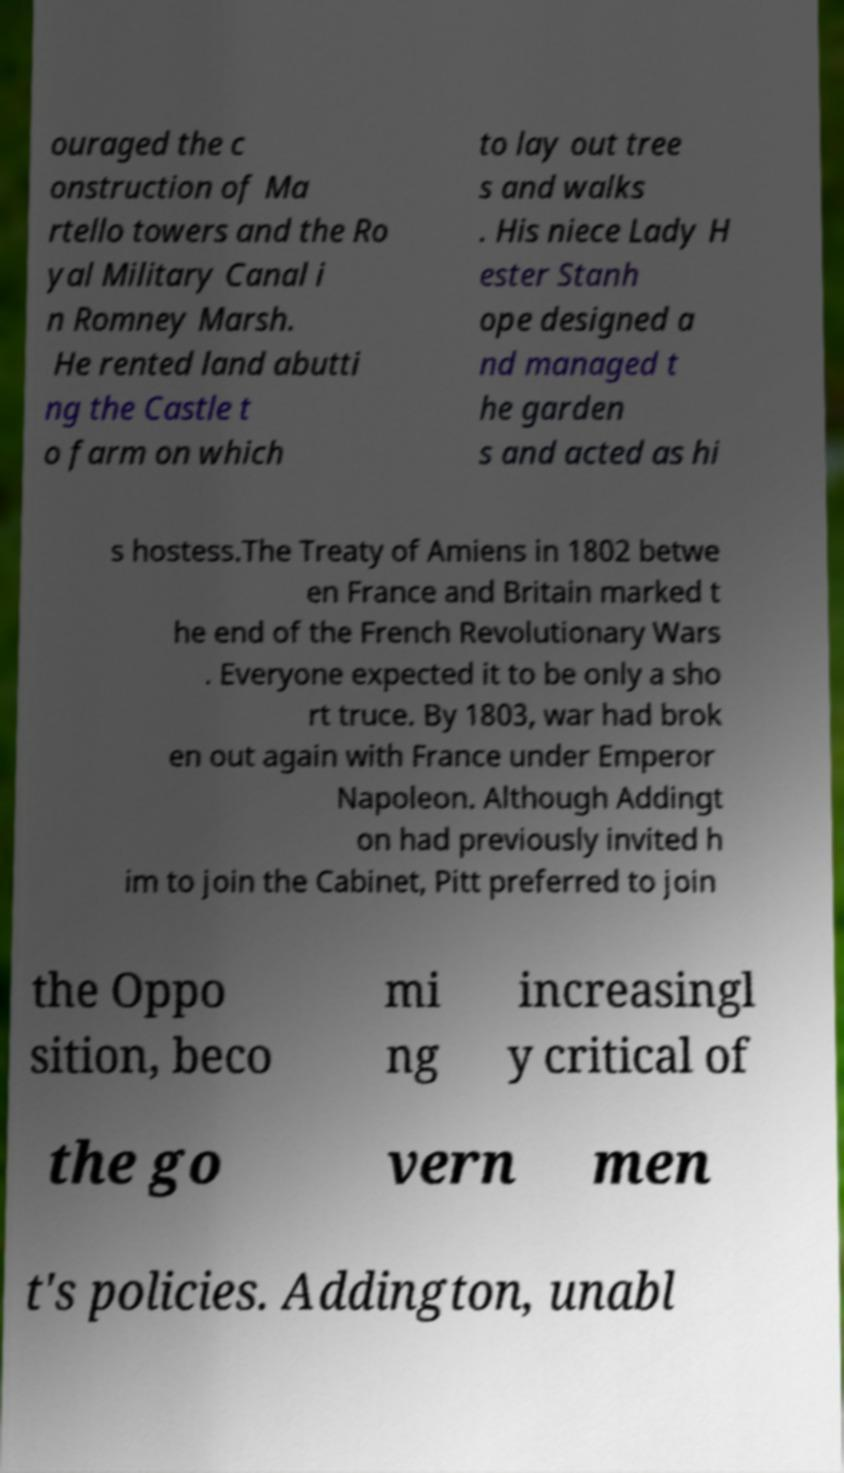For documentation purposes, I need the text within this image transcribed. Could you provide that? ouraged the c onstruction of Ma rtello towers and the Ro yal Military Canal i n Romney Marsh. He rented land abutti ng the Castle t o farm on which to lay out tree s and walks . His niece Lady H ester Stanh ope designed a nd managed t he garden s and acted as hi s hostess.The Treaty of Amiens in 1802 betwe en France and Britain marked t he end of the French Revolutionary Wars . Everyone expected it to be only a sho rt truce. By 1803, war had brok en out again with France under Emperor Napoleon. Although Addingt on had previously invited h im to join the Cabinet, Pitt preferred to join the Oppo sition, beco mi ng increasingl y critical of the go vern men t's policies. Addington, unabl 